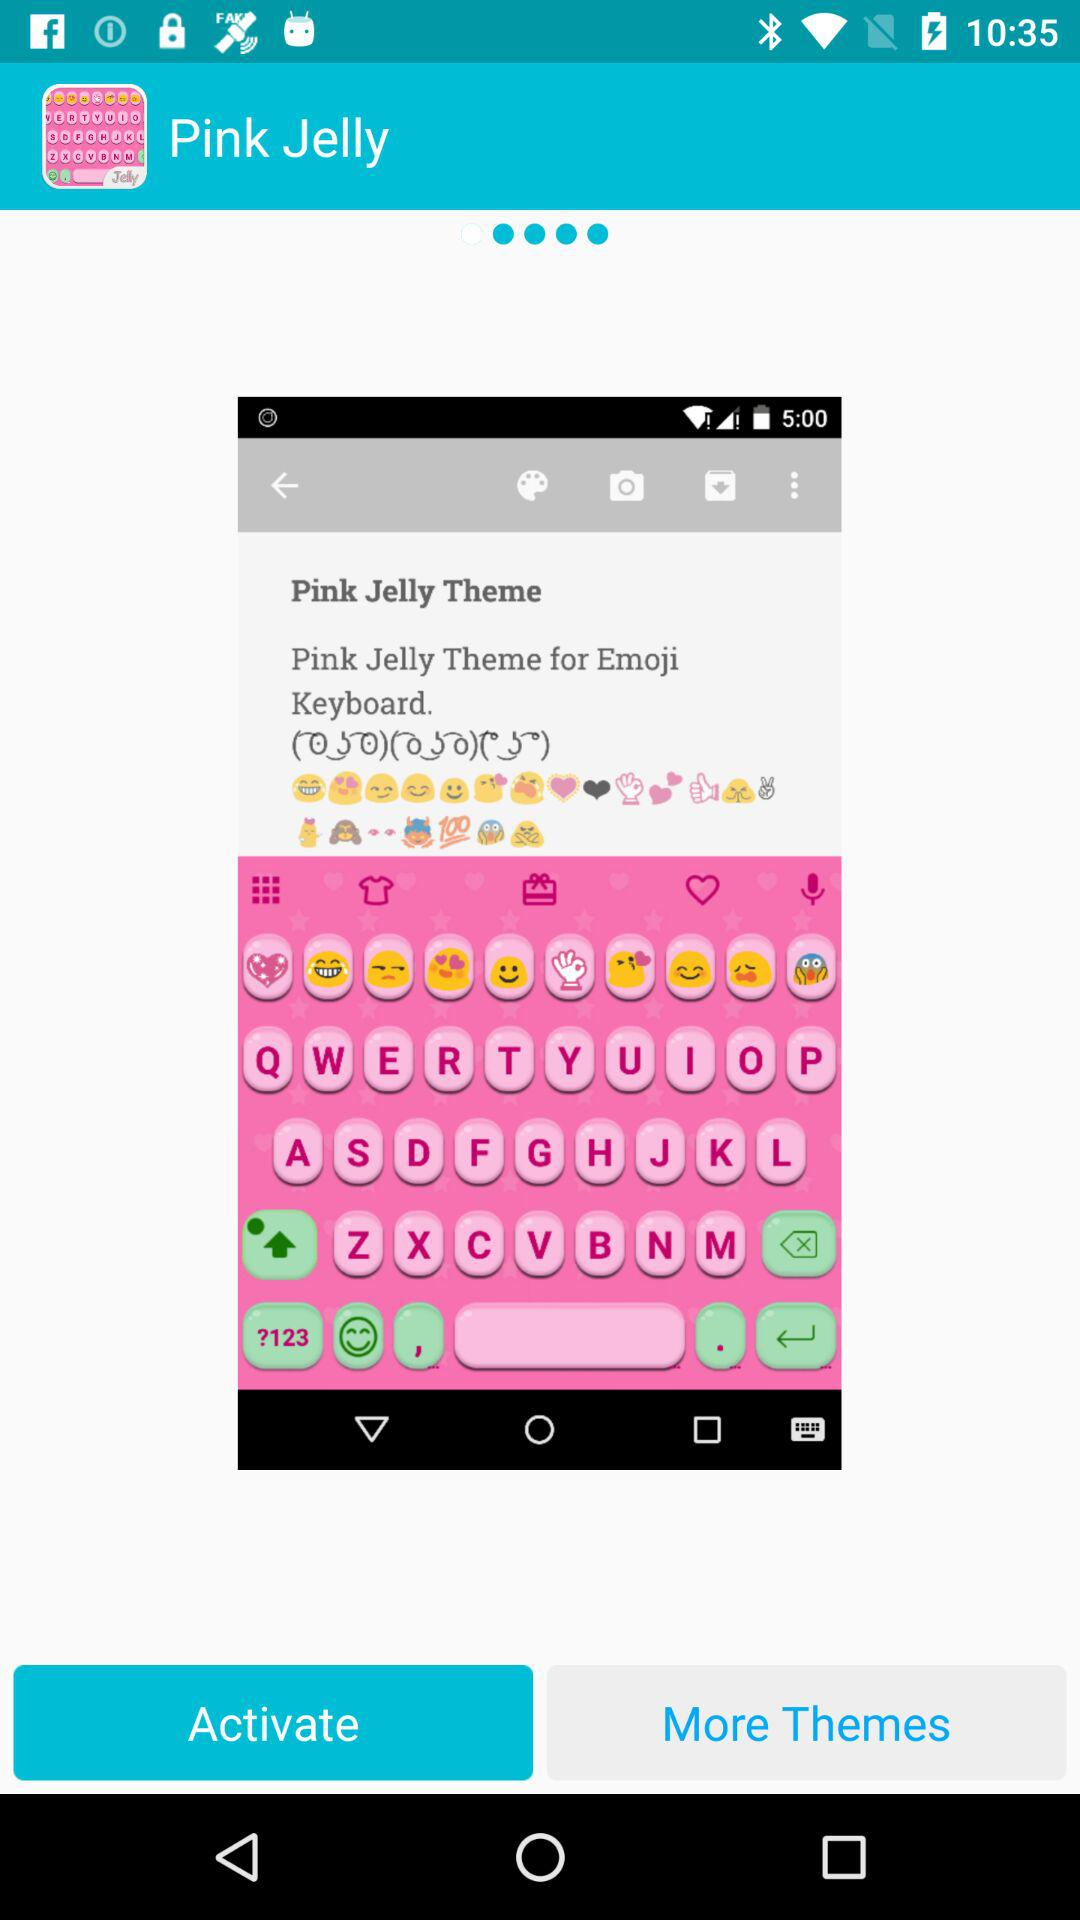What is the name of the application? The name of the application is "Pink Jelly". 